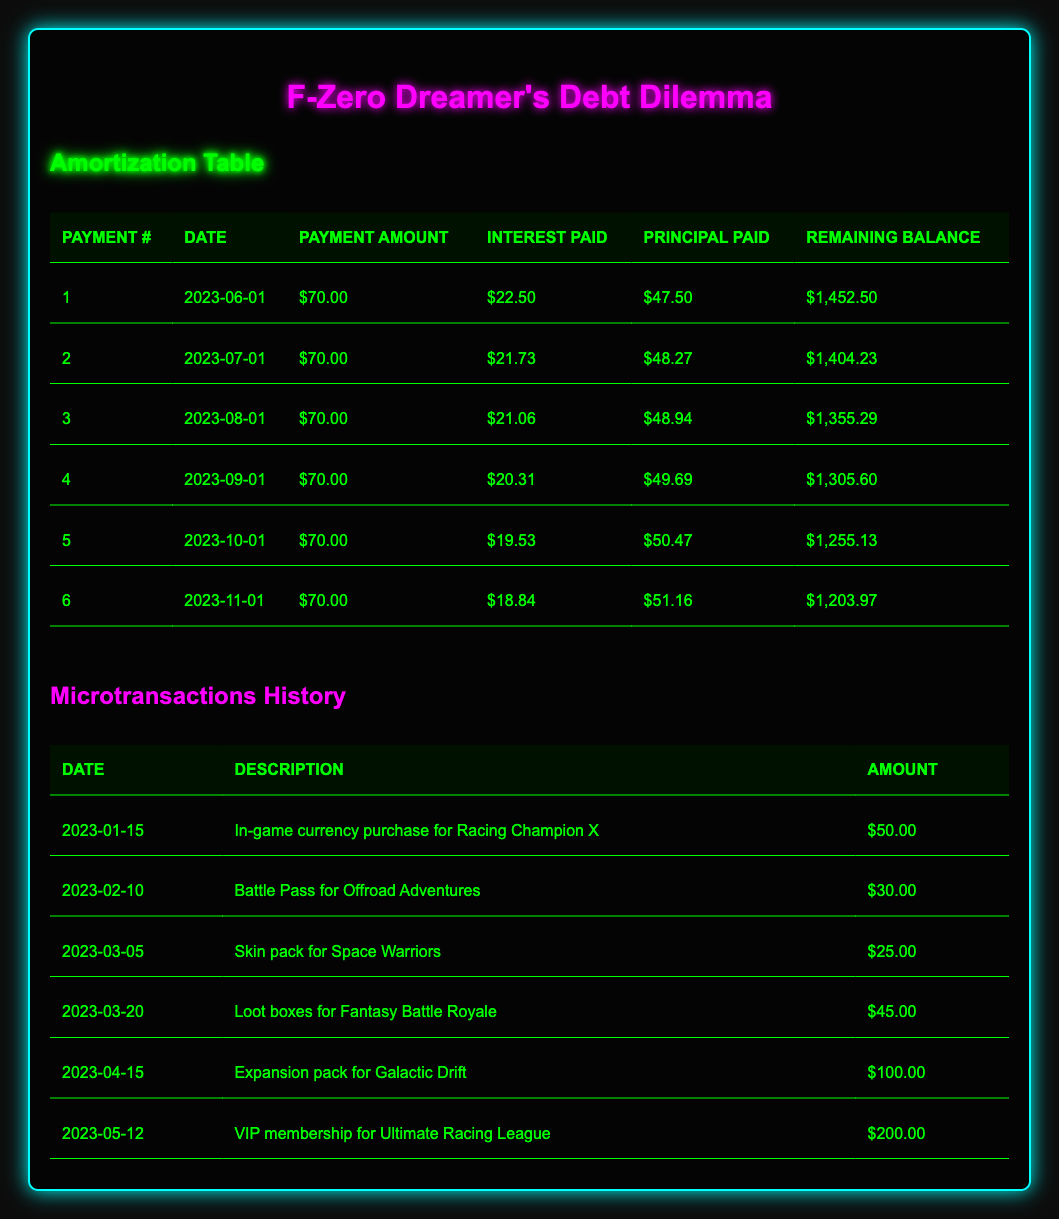What is the remaining balance after the first payment? The first payment was made on June 1, 2023, and the remaining balance after this payment is listed as $1,452.50 in the table.
Answer: $1,452.50 How much total principal has been paid after the first three payments? The principal paid in the first three payments is calculated as follows: 47.50 (first) + 48.94 (second) + 48.27 (third) = 144.71.
Answer: $144.71 Did the interest paid decrease with each payment? The interest paid for each payment is listed sequentially and shows a decrease: $22.50, $21.73, $21.06, $20.31, $19.53, and $18.84, indicating a downward trend.
Answer: Yes What is the total amount paid in interest after six payments? To find the total interest paid, sum up the interest amounts for all six payments: 22.50 + 21.73 + 21.06 + 20.31 + 19.53 + 18.84 = 123.97.
Answer: $123.97 What is the average amount paid in principal for the first six payments? The total principal paid across the six payments is 47.50 + 48.27 + 48.94 + 49.69 + 50.47 + 51.16 = 296.03, and dividing this by 6 gives an average of 49.34.
Answer: $49.34 What was the highest payment made towards principal in a single month? Reviewing the principal paid each month, the highest value is 51.16, which occurred in the sixth payment.
Answer: $51.16 How many months will it take to completely pay off the debt if the payments remain consistent? Based on the current minimum payment of 70, we calculate the total remaining balance and pay off amounts to see it takes a total of 22 payments to pay off the balance at a consistent rate.
Answer: 22 months Was there a specific month where the principal paid exceeded $50? Looking at the principal amounts, the only months where the principal paid exceeded $50 are the fifth (50.47) and sixth (51.16) payments.
Answer: Yes 